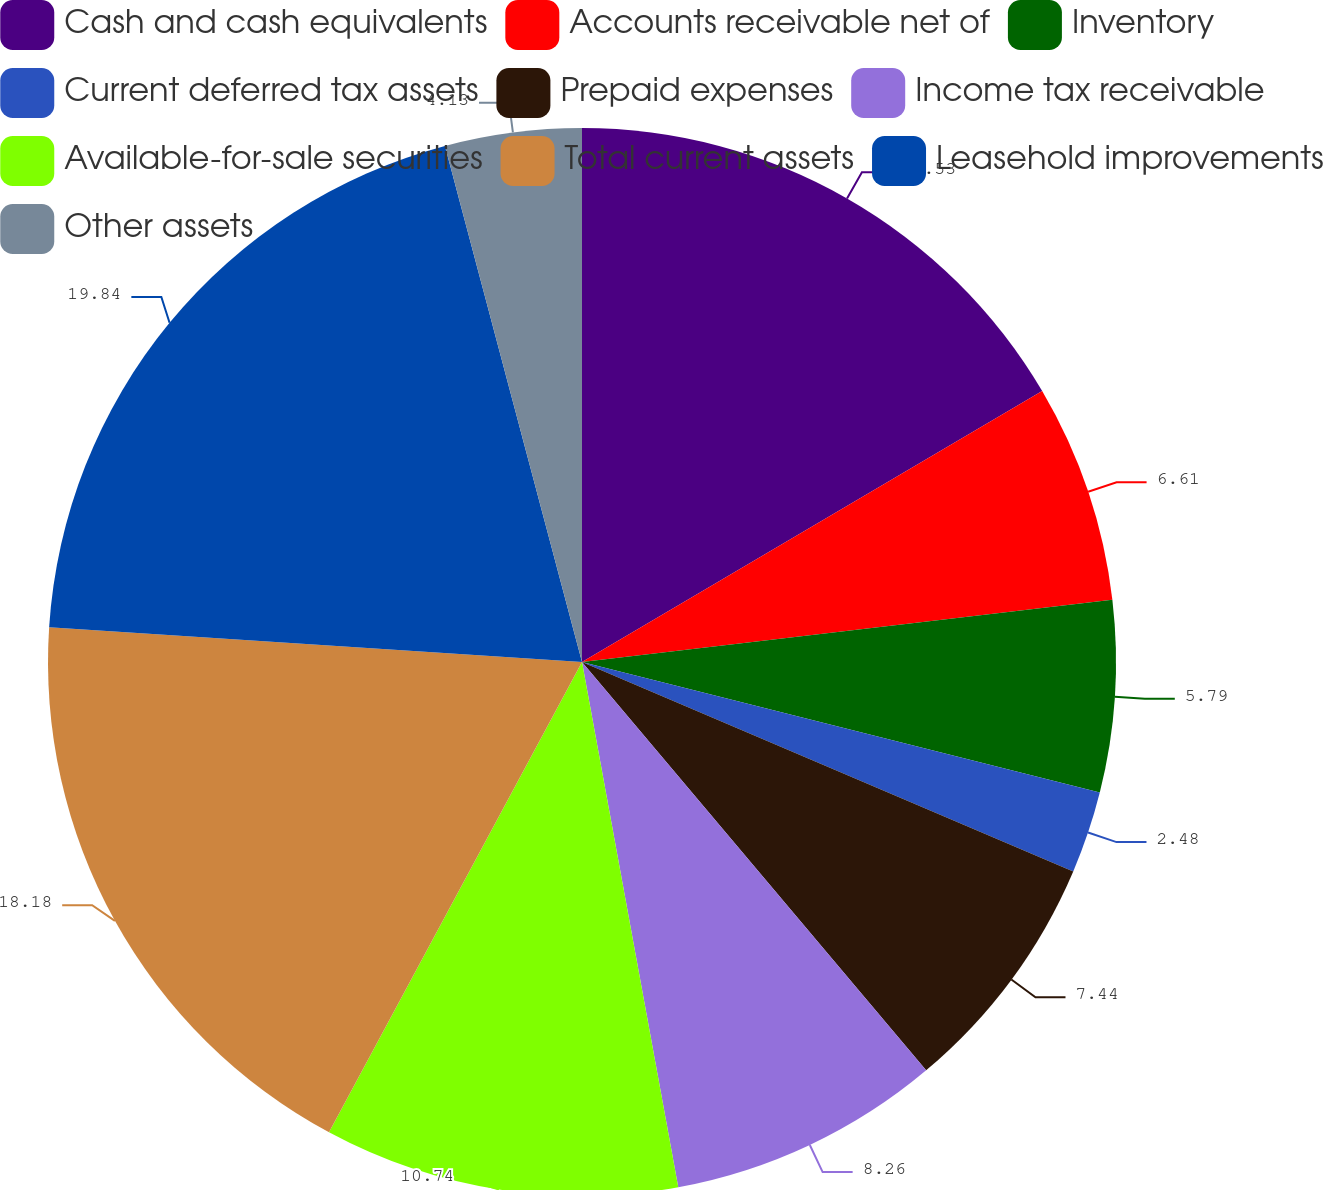Convert chart to OTSL. <chart><loc_0><loc_0><loc_500><loc_500><pie_chart><fcel>Cash and cash equivalents<fcel>Accounts receivable net of<fcel>Inventory<fcel>Current deferred tax assets<fcel>Prepaid expenses<fcel>Income tax receivable<fcel>Available-for-sale securities<fcel>Total current assets<fcel>Leasehold improvements<fcel>Other assets<nl><fcel>16.53%<fcel>6.61%<fcel>5.79%<fcel>2.48%<fcel>7.44%<fcel>8.26%<fcel>10.74%<fcel>18.18%<fcel>19.83%<fcel>4.13%<nl></chart> 